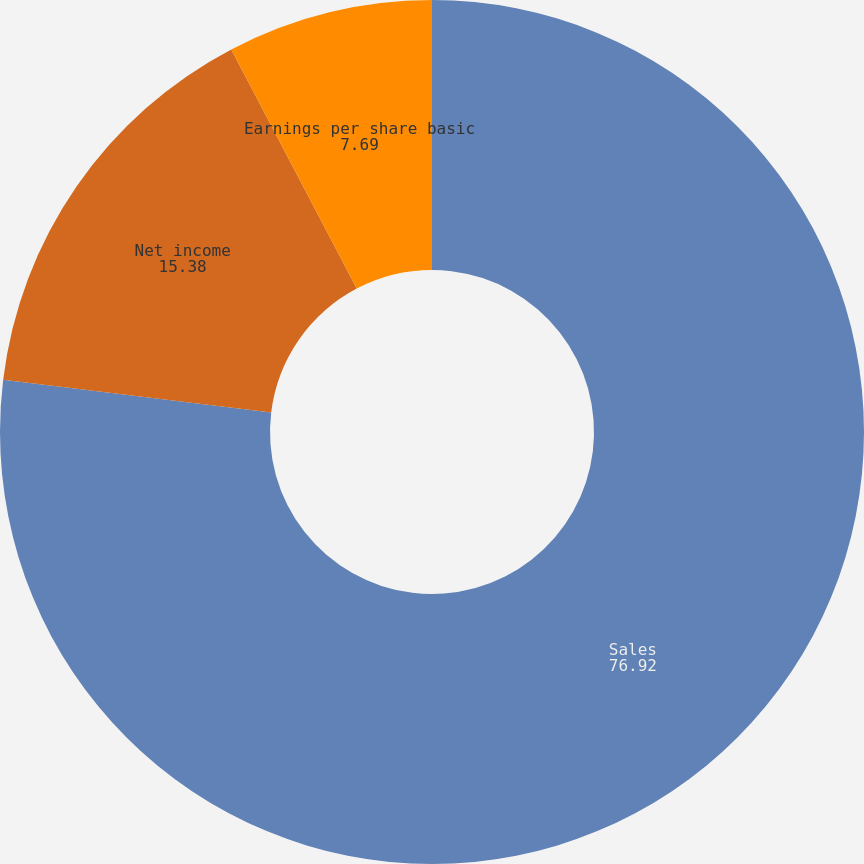<chart> <loc_0><loc_0><loc_500><loc_500><pie_chart><fcel>Sales<fcel>Net income<fcel>Earnings per share basic<fcel>Earnings per share diluted<nl><fcel>76.92%<fcel>15.38%<fcel>7.69%<fcel>0.0%<nl></chart> 